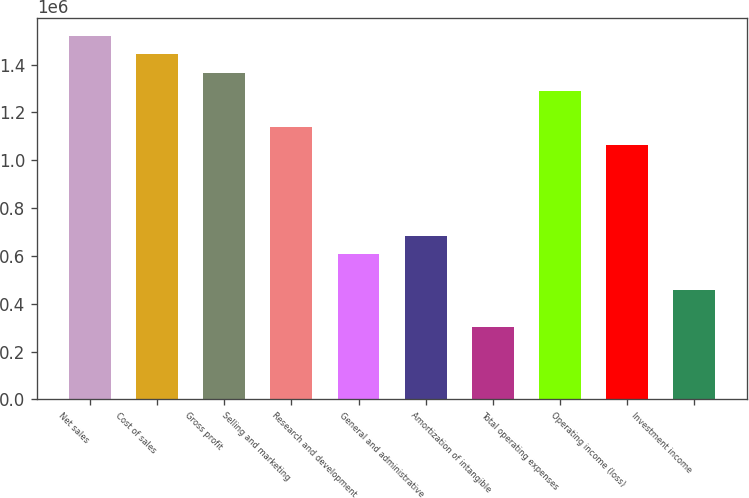Convert chart. <chart><loc_0><loc_0><loc_500><loc_500><bar_chart><fcel>Net sales<fcel>Cost of sales<fcel>Gross profit<fcel>Selling and marketing<fcel>Research and development<fcel>General and administrative<fcel>Amortization of intangible<fcel>Total operating expenses<fcel>Operating income (loss)<fcel>Investment income<nl><fcel>1.51905e+06<fcel>1.44309e+06<fcel>1.36714e+06<fcel>1.13929e+06<fcel>607619<fcel>683572<fcel>303810<fcel>1.29119e+06<fcel>1.06333e+06<fcel>455715<nl></chart> 